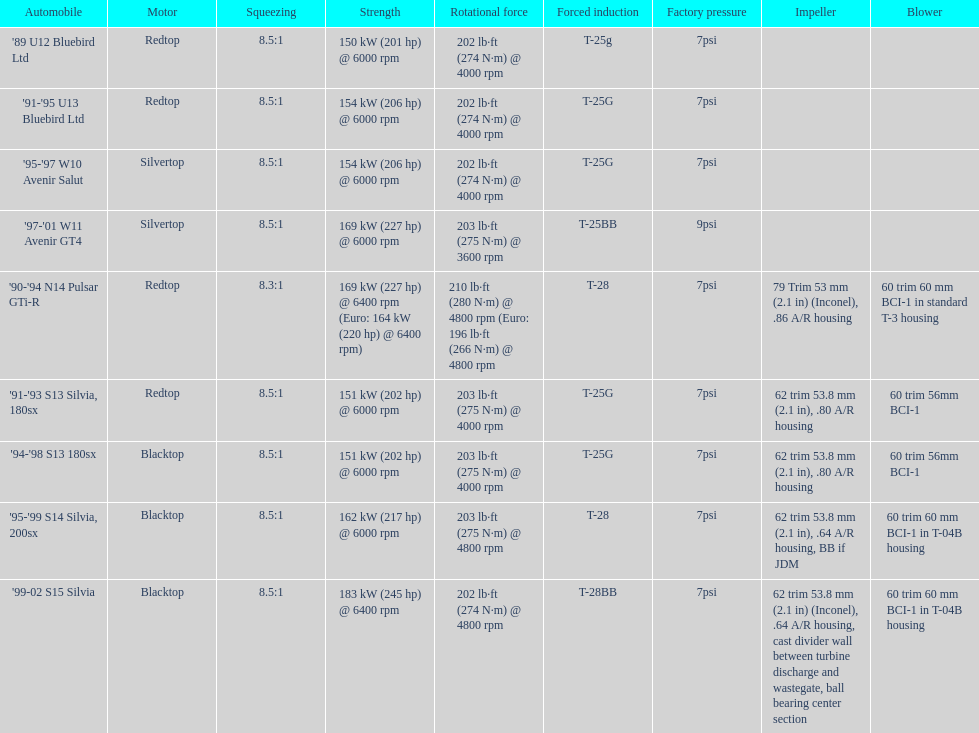Which engine has the smallest compression rate? '90-'94 N14 Pulsar GTi-R. 